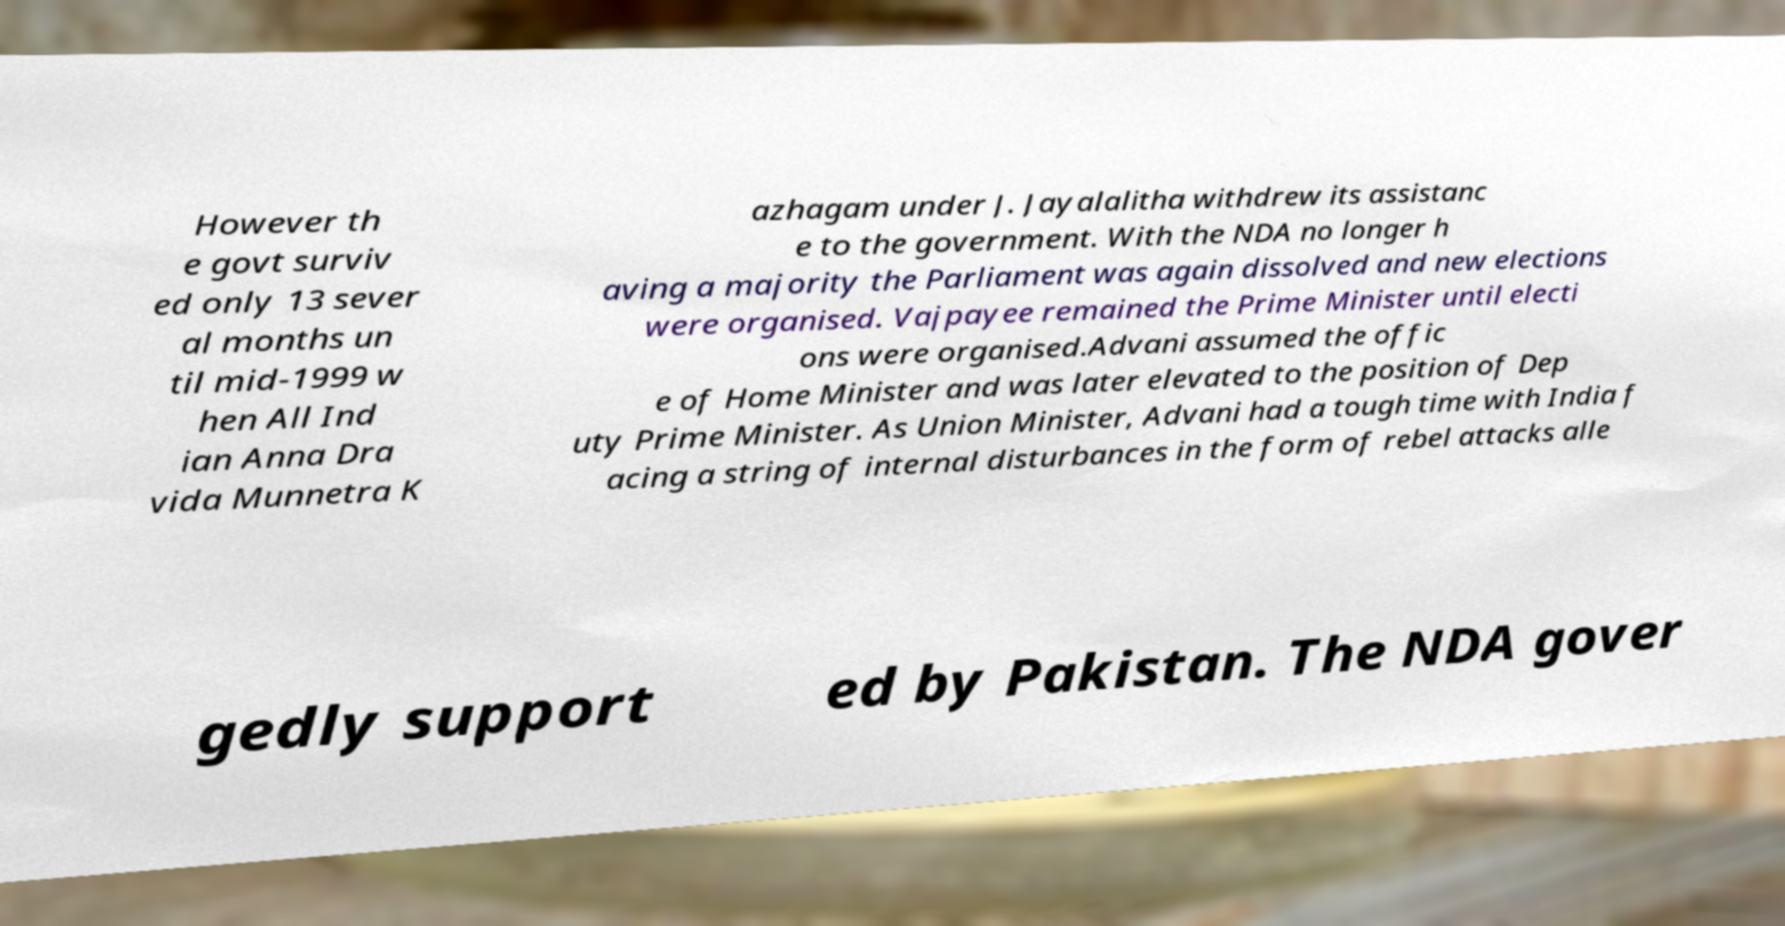Could you extract and type out the text from this image? However th e govt surviv ed only 13 sever al months un til mid-1999 w hen All Ind ian Anna Dra vida Munnetra K azhagam under J. Jayalalitha withdrew its assistanc e to the government. With the NDA no longer h aving a majority the Parliament was again dissolved and new elections were organised. Vajpayee remained the Prime Minister until electi ons were organised.Advani assumed the offic e of Home Minister and was later elevated to the position of Dep uty Prime Minister. As Union Minister, Advani had a tough time with India f acing a string of internal disturbances in the form of rebel attacks alle gedly support ed by Pakistan. The NDA gover 